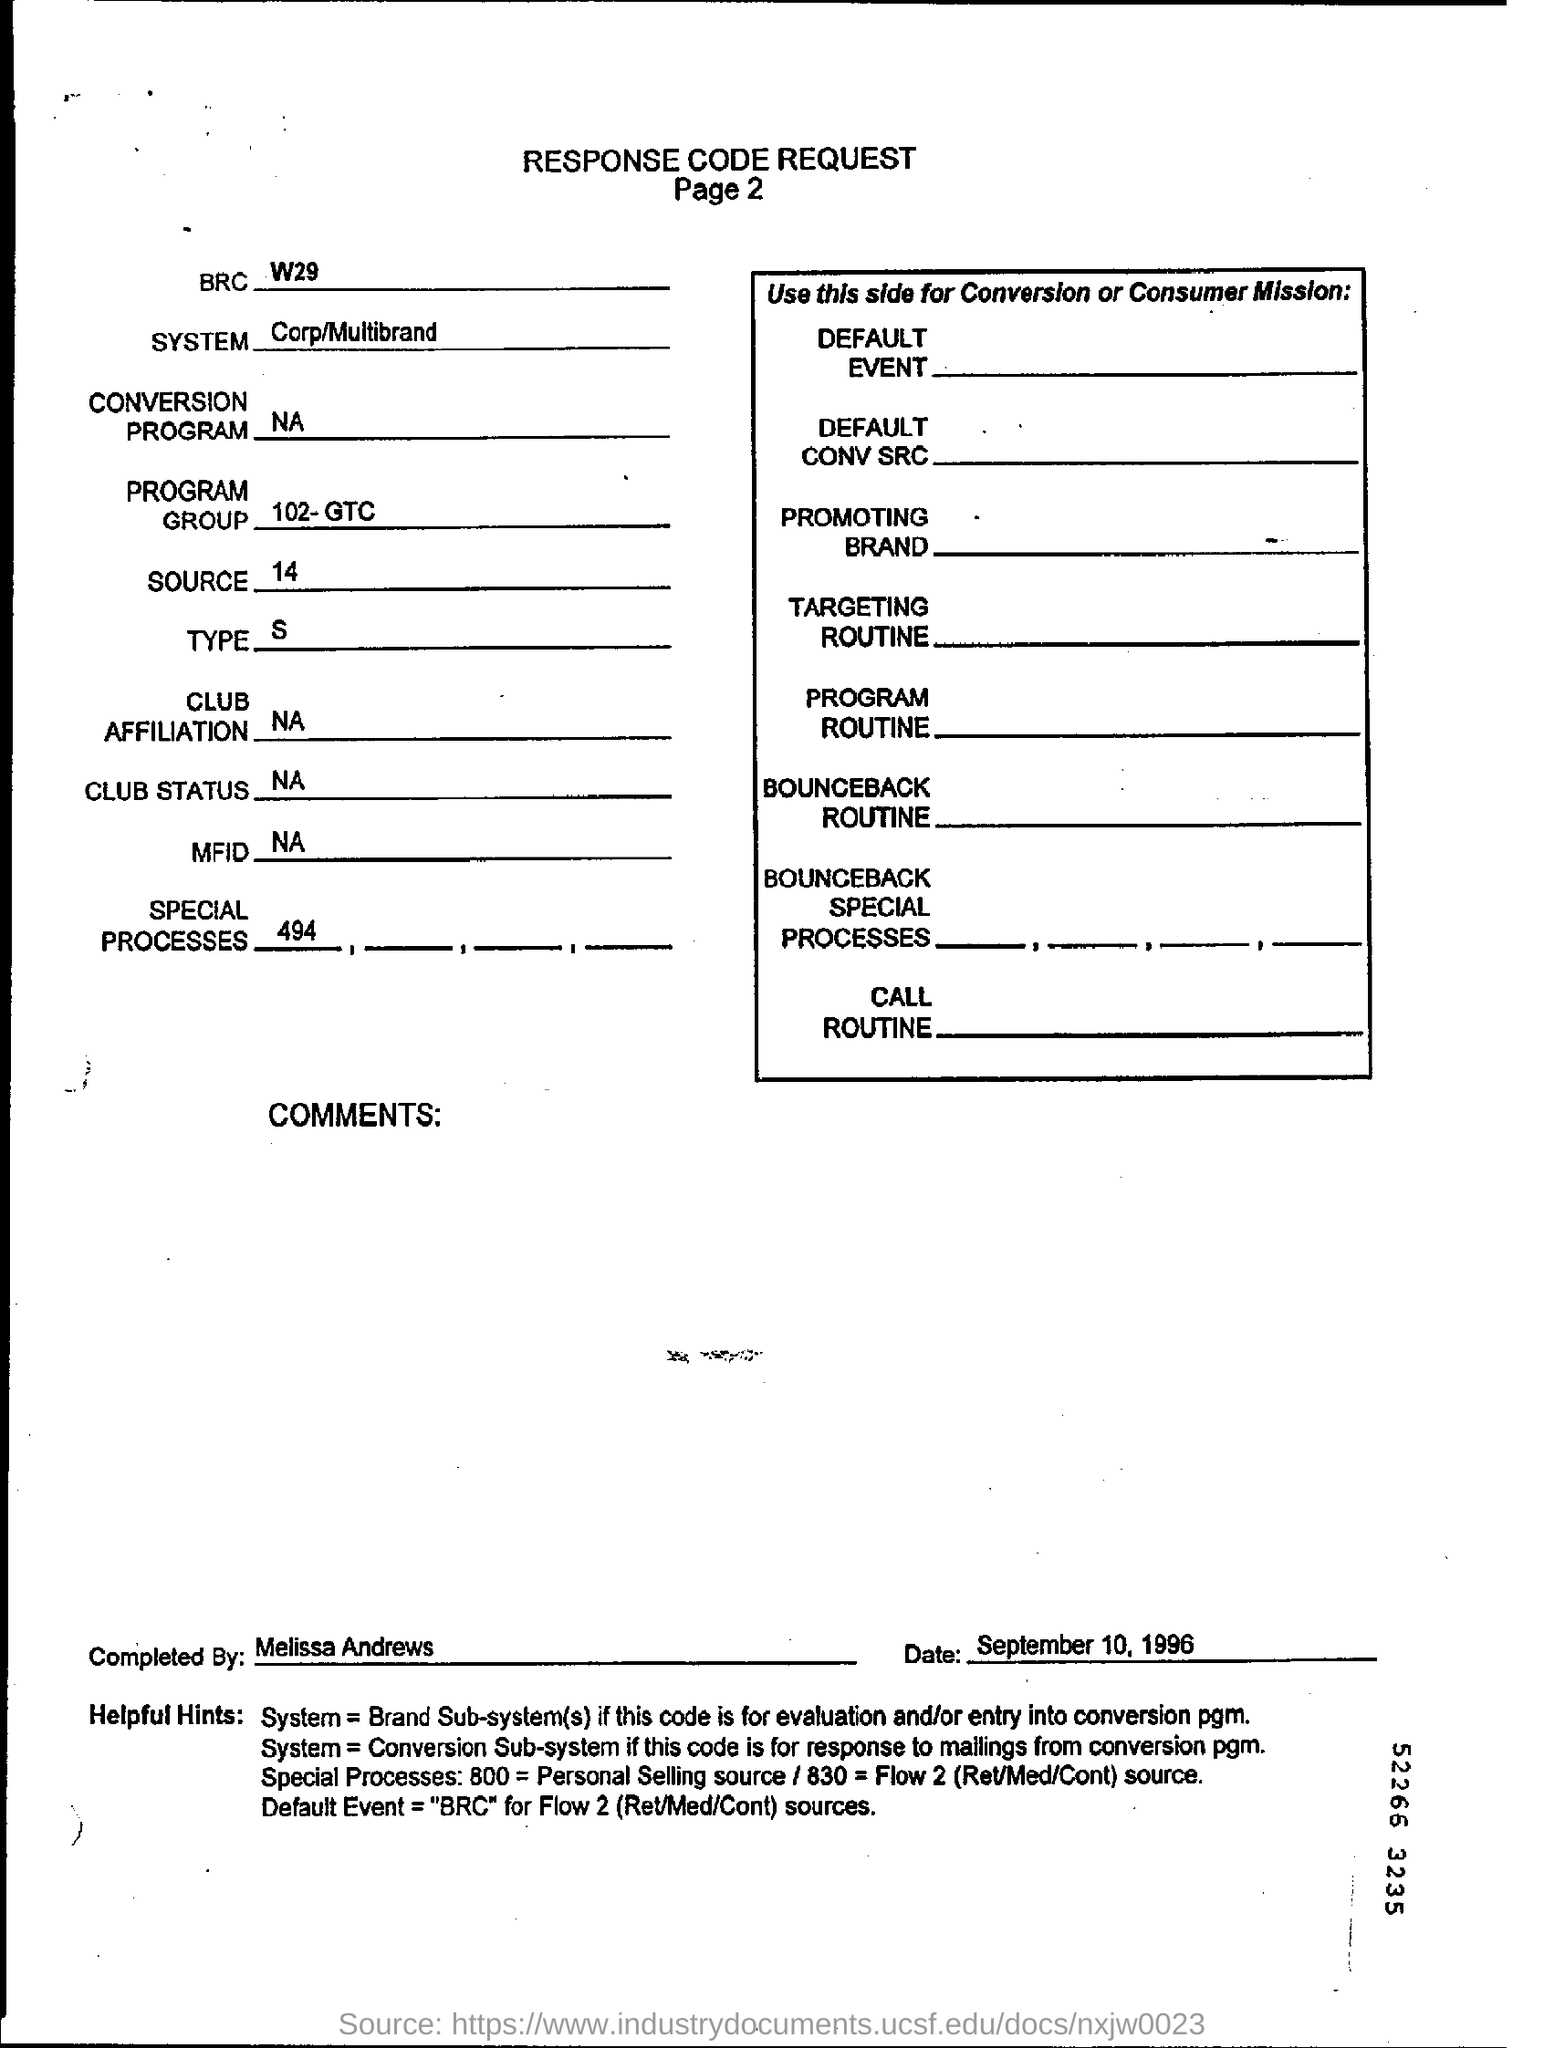Which System is specified in the request form?
Make the answer very short. Corp/Multibrand. Who completed the Request?
Offer a terse response. By Melissa Andrews. 